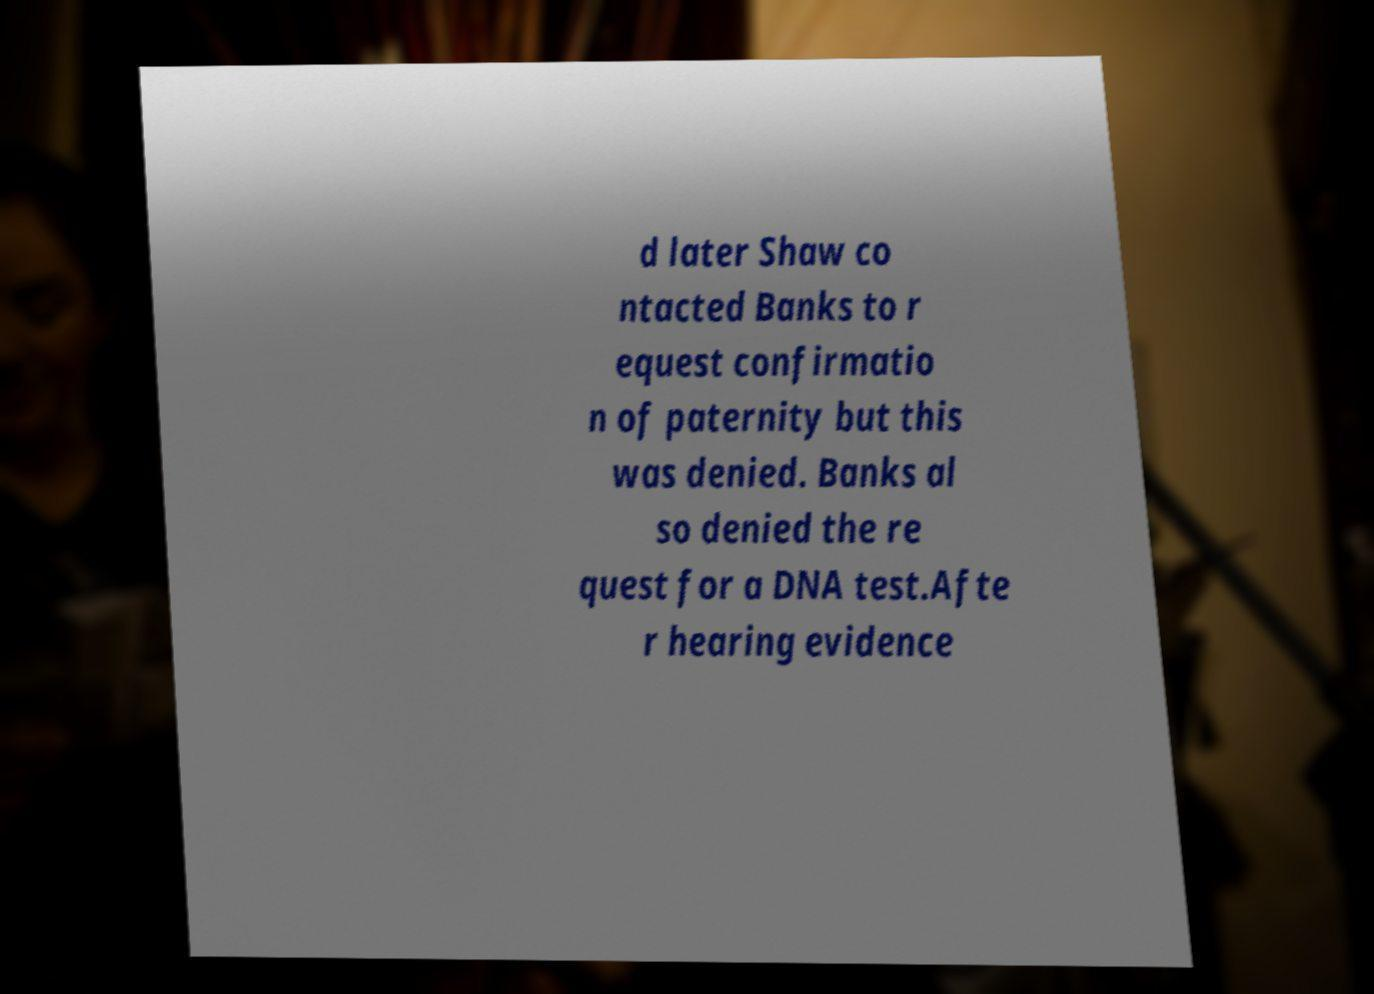There's text embedded in this image that I need extracted. Can you transcribe it verbatim? d later Shaw co ntacted Banks to r equest confirmatio n of paternity but this was denied. Banks al so denied the re quest for a DNA test.Afte r hearing evidence 